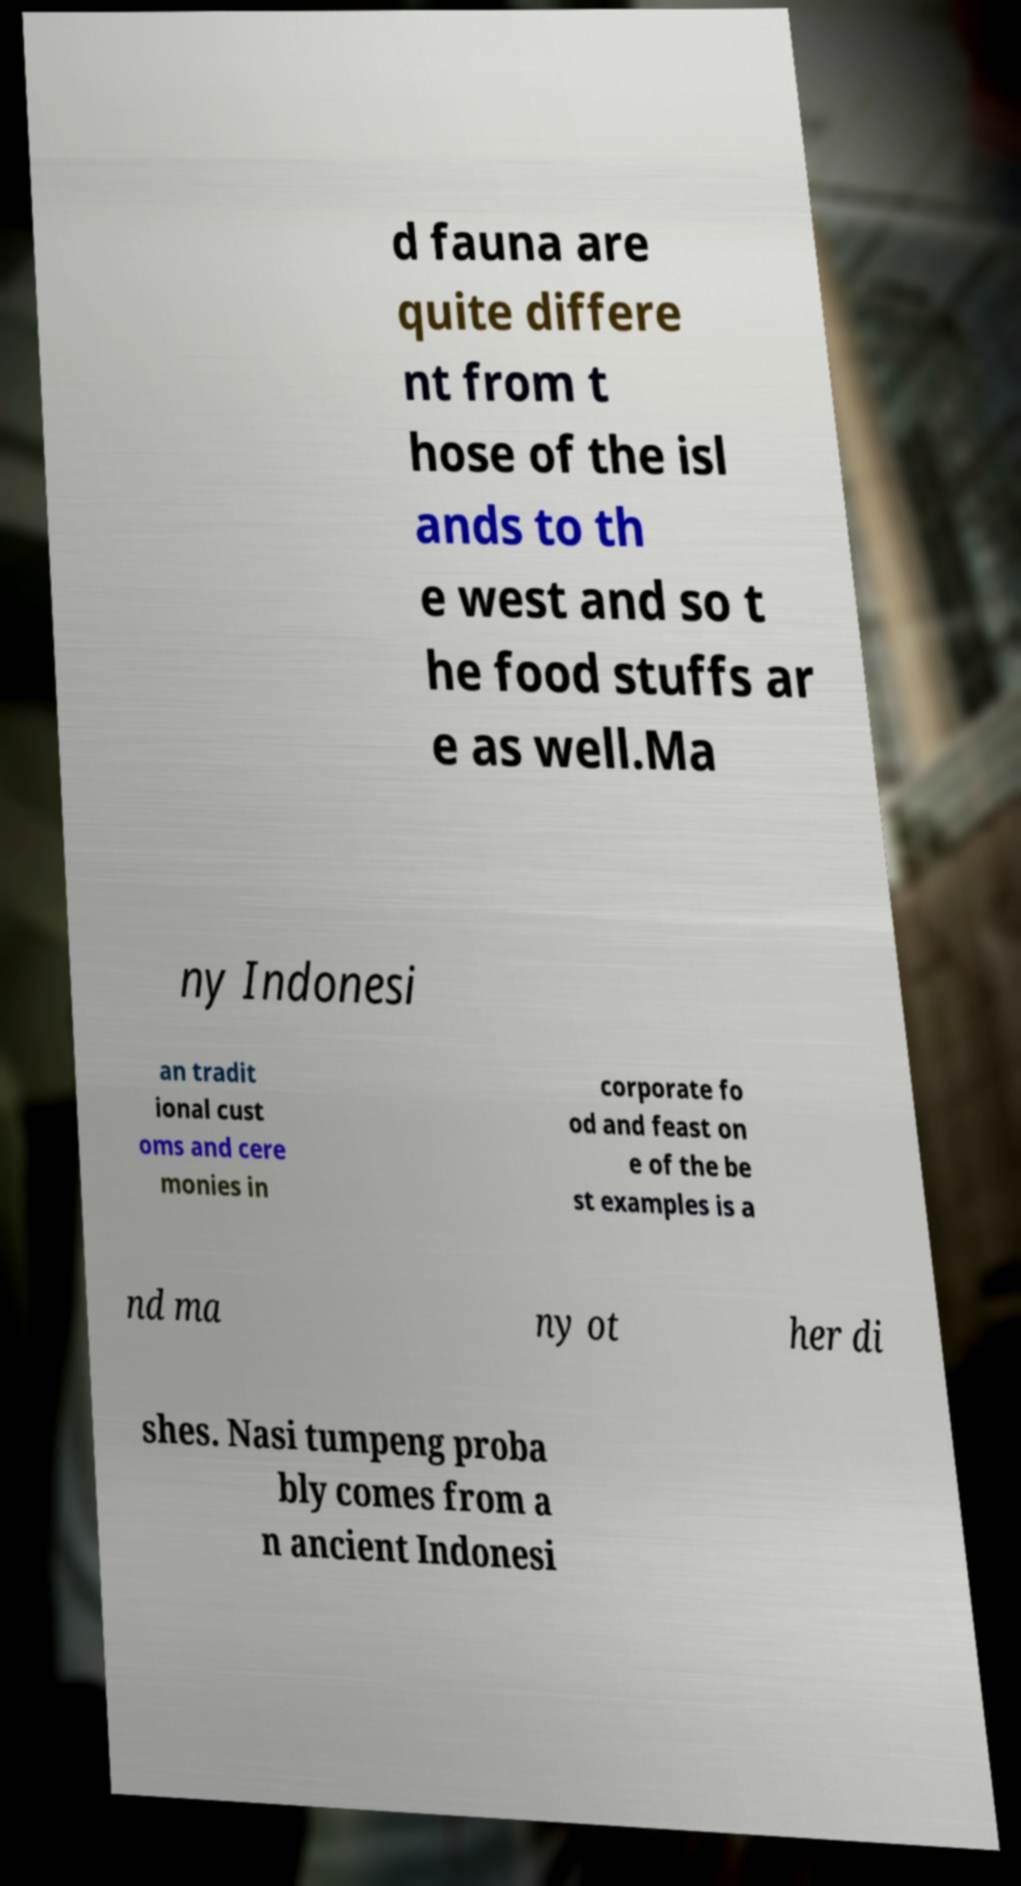Please identify and transcribe the text found in this image. d fauna are quite differe nt from t hose of the isl ands to th e west and so t he food stuffs ar e as well.Ma ny Indonesi an tradit ional cust oms and cere monies in corporate fo od and feast on e of the be st examples is a nd ma ny ot her di shes. Nasi tumpeng proba bly comes from a n ancient Indonesi 